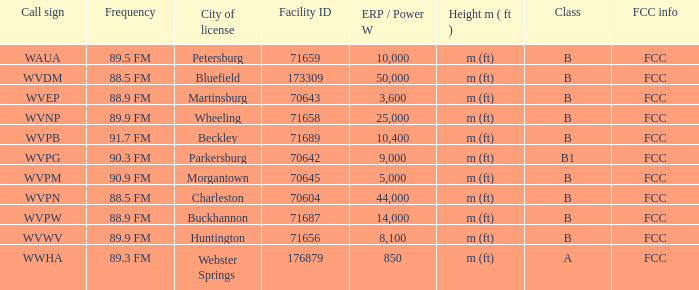What is the lowest facility ID that's in Beckley? 71689.0. 